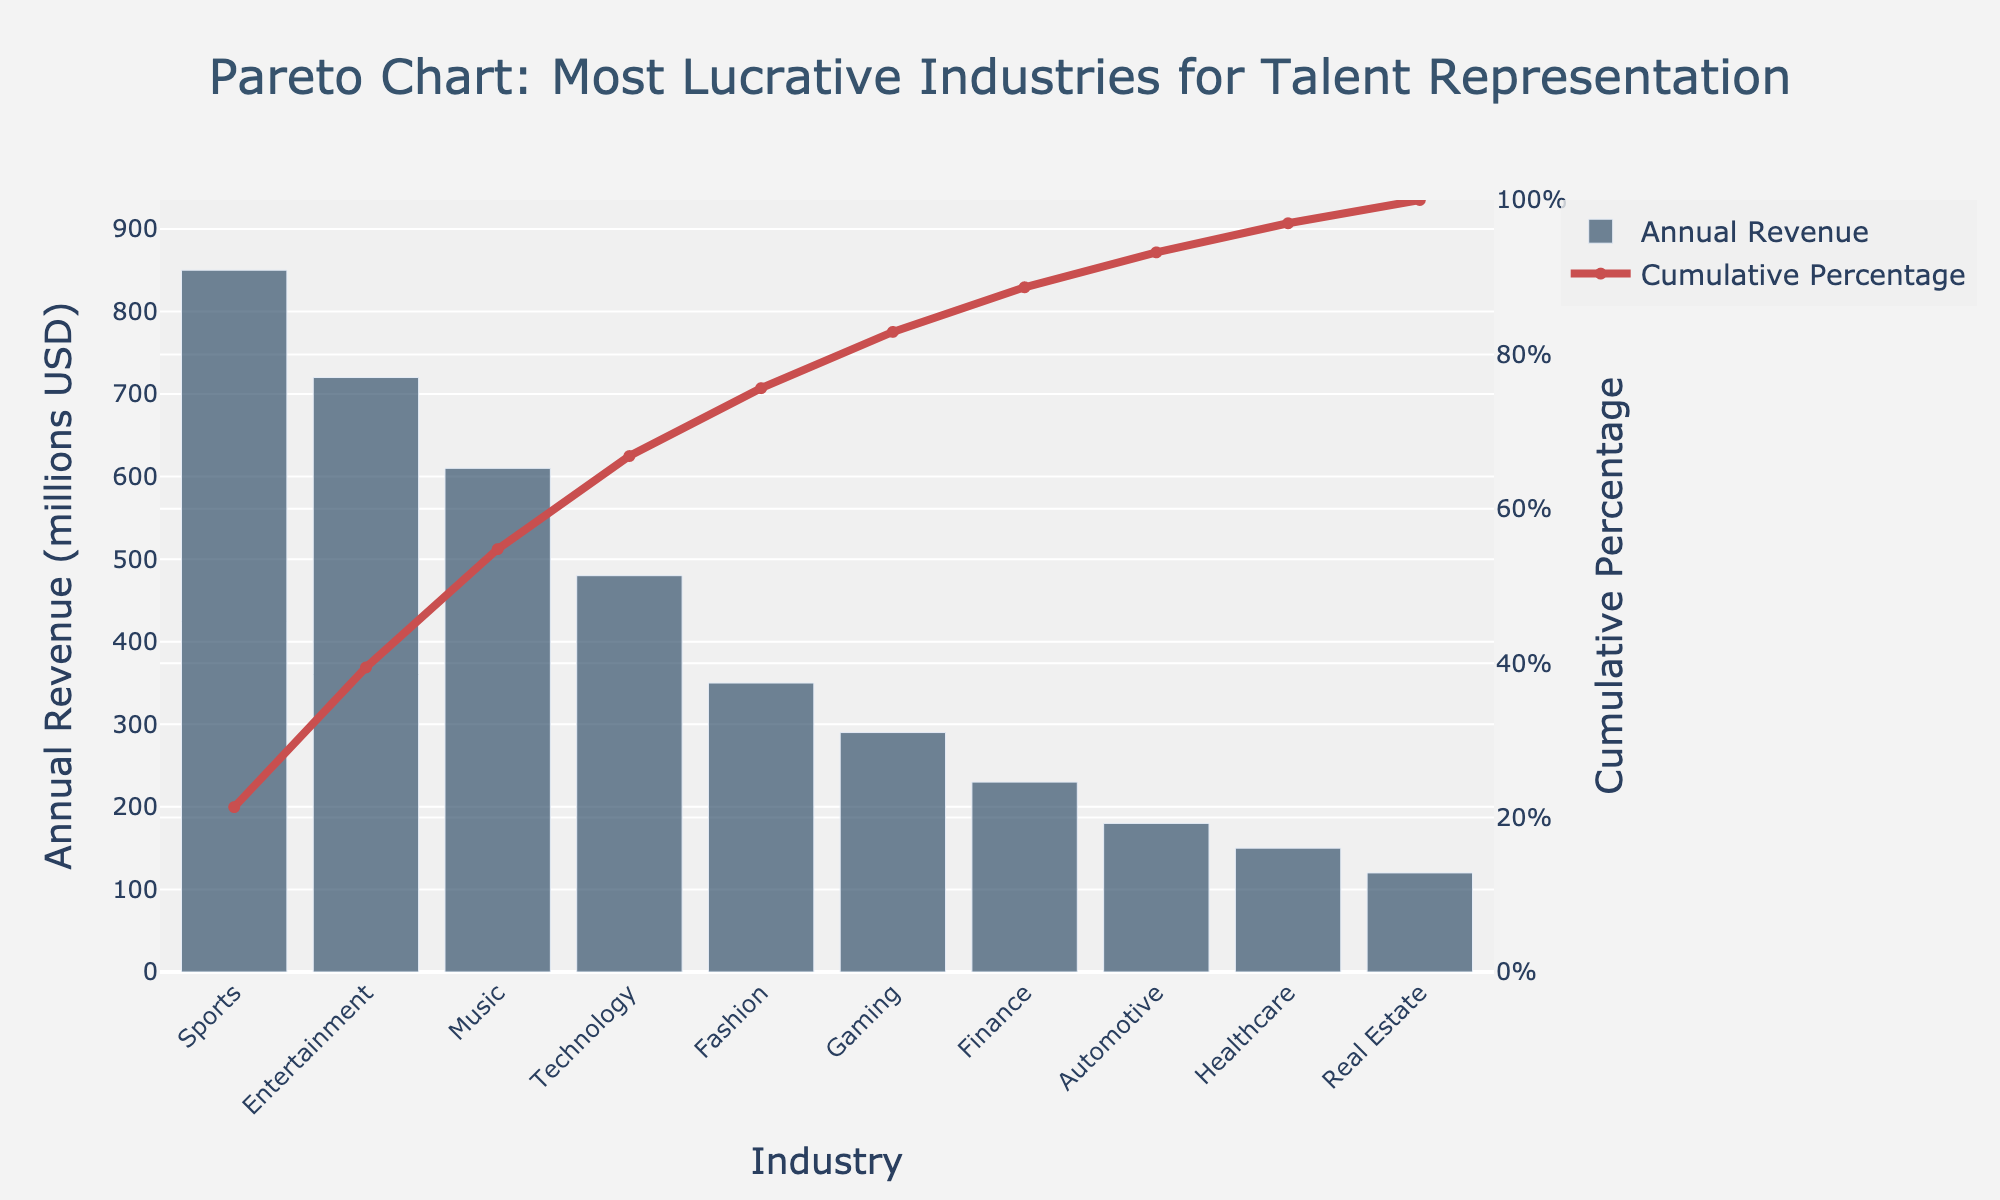What industry has the highest annual revenue? The industry with the highest bar represents the one with the highest annual revenue. This is the 'Sports' industry as indicated by the height of the bar.
Answer: Sports Which industry contributes approximately 30% to the cumulative percentage? By looking at the cumulative percentage line, the 'Music' industry aligns closest to the 30% mark on the y2-axis, given the cumulative percentage value shown on the right-hand side of the chart.
Answer: Music What is the cumulative percentage of annual revenue for the top three industries? Sum the annual revenues of the top three industries, then divide by the total revenue and multiply by 100 to get the cumulative percentage. For the top three industries (Sports, Entertainment, and Music), the cumulative percentage is (850 + 720 + 610) / (850 + 720 + 610 + 480 + 350 + 290 + 230 + 180 + 150 + 120) * 100. This sums up to approximately 72%.
Answer: 72% Identify the industry with the smallest contribution to the overall cumulative percentage. The industry with the smallest contribution is indicated by the shortest bar in the Pareto chart, which is the 'Real Estate' industry.
Answer: Real Estate What is the difference in annual revenue between the Technology and Finance industries? The bar heights for Technology and Finance represent their annual revenues, which are 480 million USD and 230 million USD respectively. The difference is obtained by subtracting Finance's revenue from Technology's revenue: 480 - 230 = 250 million USD.
Answer: 250 million USD Between the Gaming and Automotive industries, which one contributes more to the cumulative percentage? By comparing the height of the bars for Gaming and Automotive, it is clear that Gaming has a higher annual revenue (290 million USD) compared to Automotive (180 million USD). Thus, Gaming contributes more to the cumulative percentage.
Answer: Gaming By what cumulative percentage does the Fashion industry contribute? Locate the 'Fashion' industry on the x-axis and follow up to the 'Cumulative Percentage' line on the y2-axis. The contribution is comprised between 68% and 77%.
Answer: 68%-77% How many industries need to be combined to reach at least 50% of the cumulative percentage? Sum the cumulative percentages from the top down until reaching or exceeding 50%. The top three industries (Sports, Entertainment, Music) together surpass this threshold at approximately 72%.
Answer: 3 industries What is the annual revenue of the industry just before the cumulative percentage line crosses 80%? Find where the cumulative percentage line crosses the 80% mark on the y2-axis and trace down to the corresponding bar. This is the 'Gaming' industry which precedes this point.
Answer: 290 million USD Which industry shows a contribution that causes the cumulative percentage to finally surpass 90%? Follow the cumulative percentage line until it crosses the 90% mark on the y2-axis. The corresponding industry right after that point is the 'Real Estate' industry.
Answer: Real Estate 